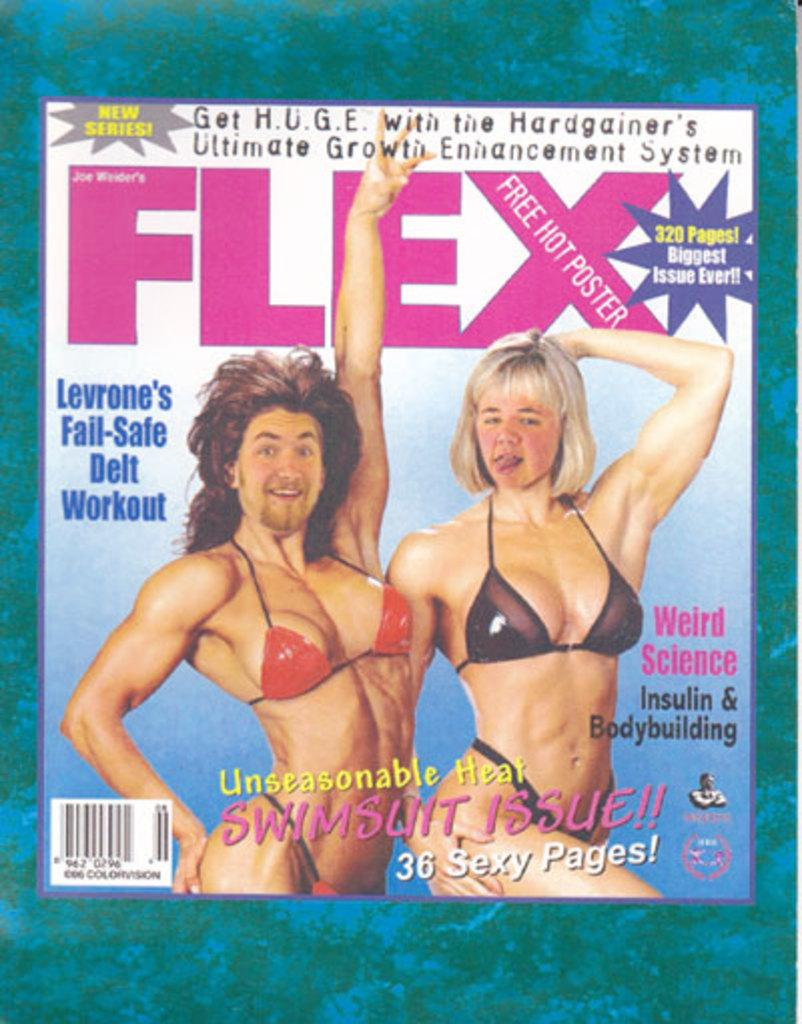What is the main object in the picture? There is a magazine in the picture. What can be seen on the front page of the magazine? The magazine has a front page with pictures of two people. Are there any other details on the magazine cover? Yes, there is some information on the magazine cover. What type of chain is connecting the two people on the magazine cover? There is no chain connecting the two people on the magazine cover; they are simply depicted in the images. 